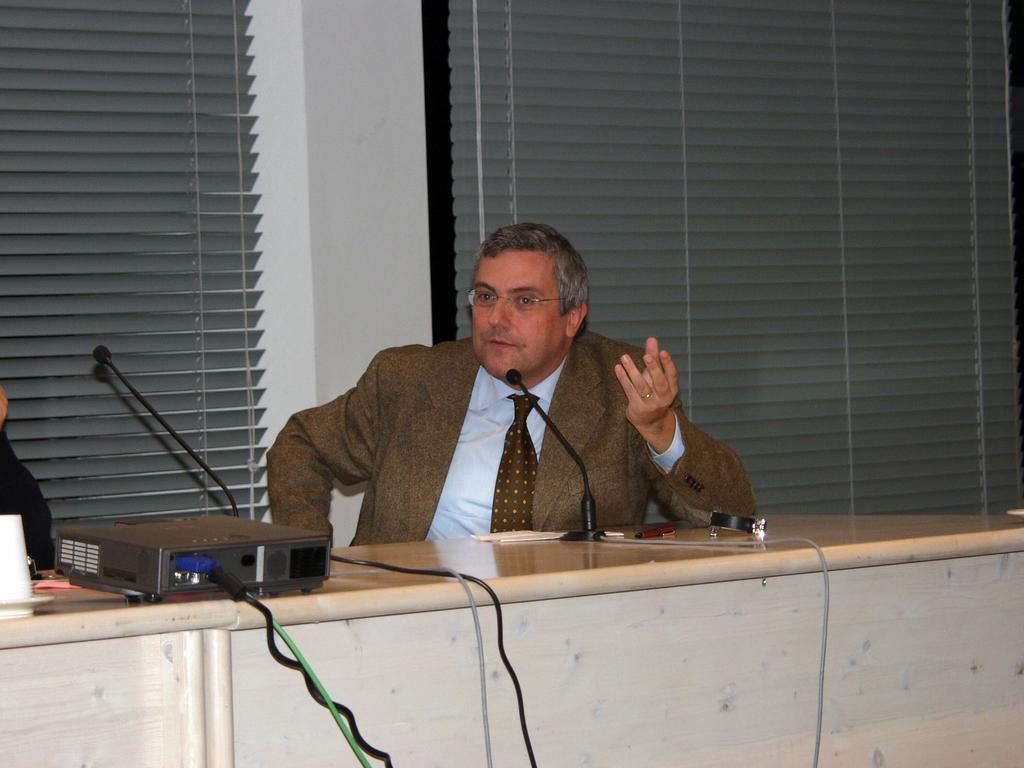Could you give a brief overview of what you see in this image? In this picture there is a man who is sitting in the center of the image and there is a mic in front of him on a table, there are windows in the background area of the image. 